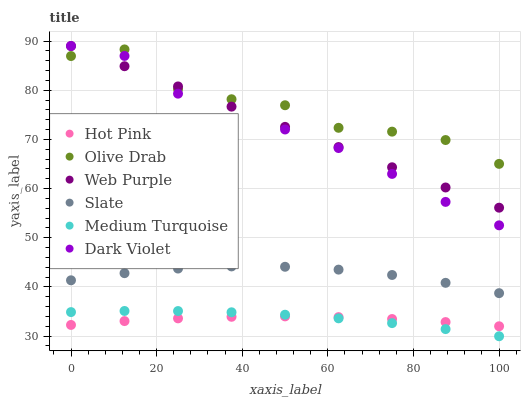Does Hot Pink have the minimum area under the curve?
Answer yes or no. Yes. Does Olive Drab have the maximum area under the curve?
Answer yes or no. Yes. Does Dark Violet have the minimum area under the curve?
Answer yes or no. No. Does Dark Violet have the maximum area under the curve?
Answer yes or no. No. Is Web Purple the smoothest?
Answer yes or no. Yes. Is Olive Drab the roughest?
Answer yes or no. Yes. Is Hot Pink the smoothest?
Answer yes or no. No. Is Hot Pink the roughest?
Answer yes or no. No. Does Medium Turquoise have the lowest value?
Answer yes or no. Yes. Does Hot Pink have the lowest value?
Answer yes or no. No. Does Web Purple have the highest value?
Answer yes or no. Yes. Does Hot Pink have the highest value?
Answer yes or no. No. Is Medium Turquoise less than Dark Violet?
Answer yes or no. Yes. Is Olive Drab greater than Hot Pink?
Answer yes or no. Yes. Does Web Purple intersect Dark Violet?
Answer yes or no. Yes. Is Web Purple less than Dark Violet?
Answer yes or no. No. Is Web Purple greater than Dark Violet?
Answer yes or no. No. Does Medium Turquoise intersect Dark Violet?
Answer yes or no. No. 